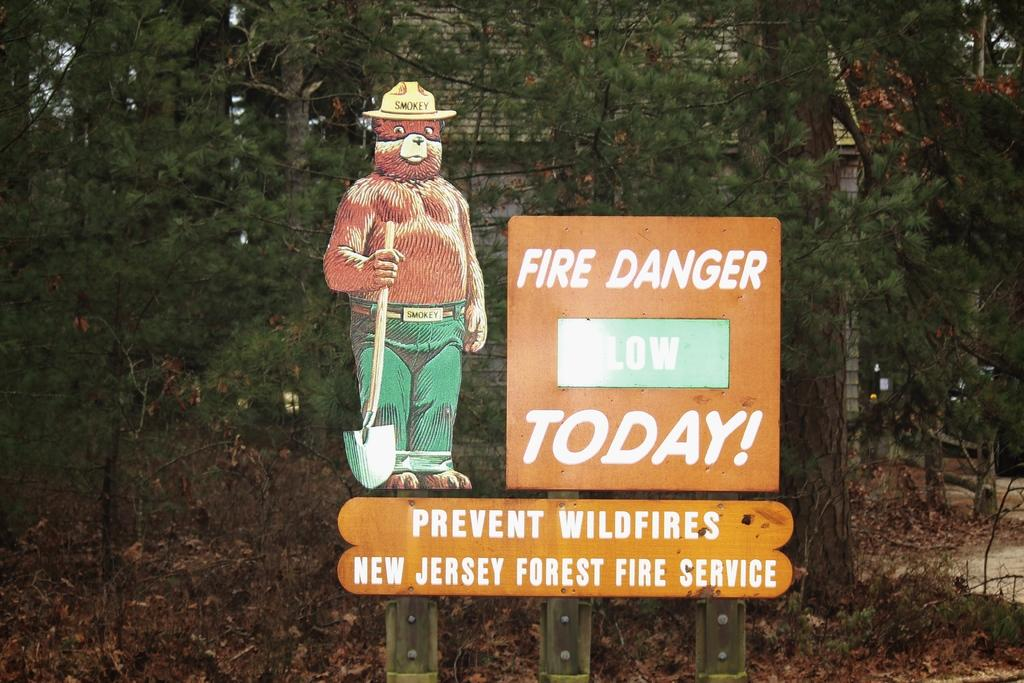What type of structure is visible in the image? There is a house in the image. What natural elements can be seen in the image? There are many trees and dry leaves on the ground in the image. What man-made object is present in the image? There is a sign board in the image. Where is the baby playing in the image? There is no baby present in the image. What type of earth can be seen in the image? The image does not show any specific type of earth; it only shows a house, trees, dry leaves, and a sign board. 